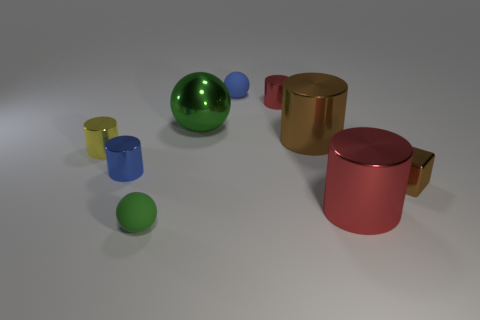Subtract all yellow cylinders. How many cylinders are left? 4 Subtract all small red metallic cylinders. How many cylinders are left? 4 Subtract all green cylinders. Subtract all gray balls. How many cylinders are left? 5 Add 1 brown cubes. How many objects exist? 10 Subtract all spheres. How many objects are left? 6 Add 3 small brown objects. How many small brown objects are left? 4 Add 6 tiny cyan metal objects. How many tiny cyan metal objects exist? 6 Subtract 0 gray cylinders. How many objects are left? 9 Subtract all large brown cylinders. Subtract all tiny brown matte blocks. How many objects are left? 8 